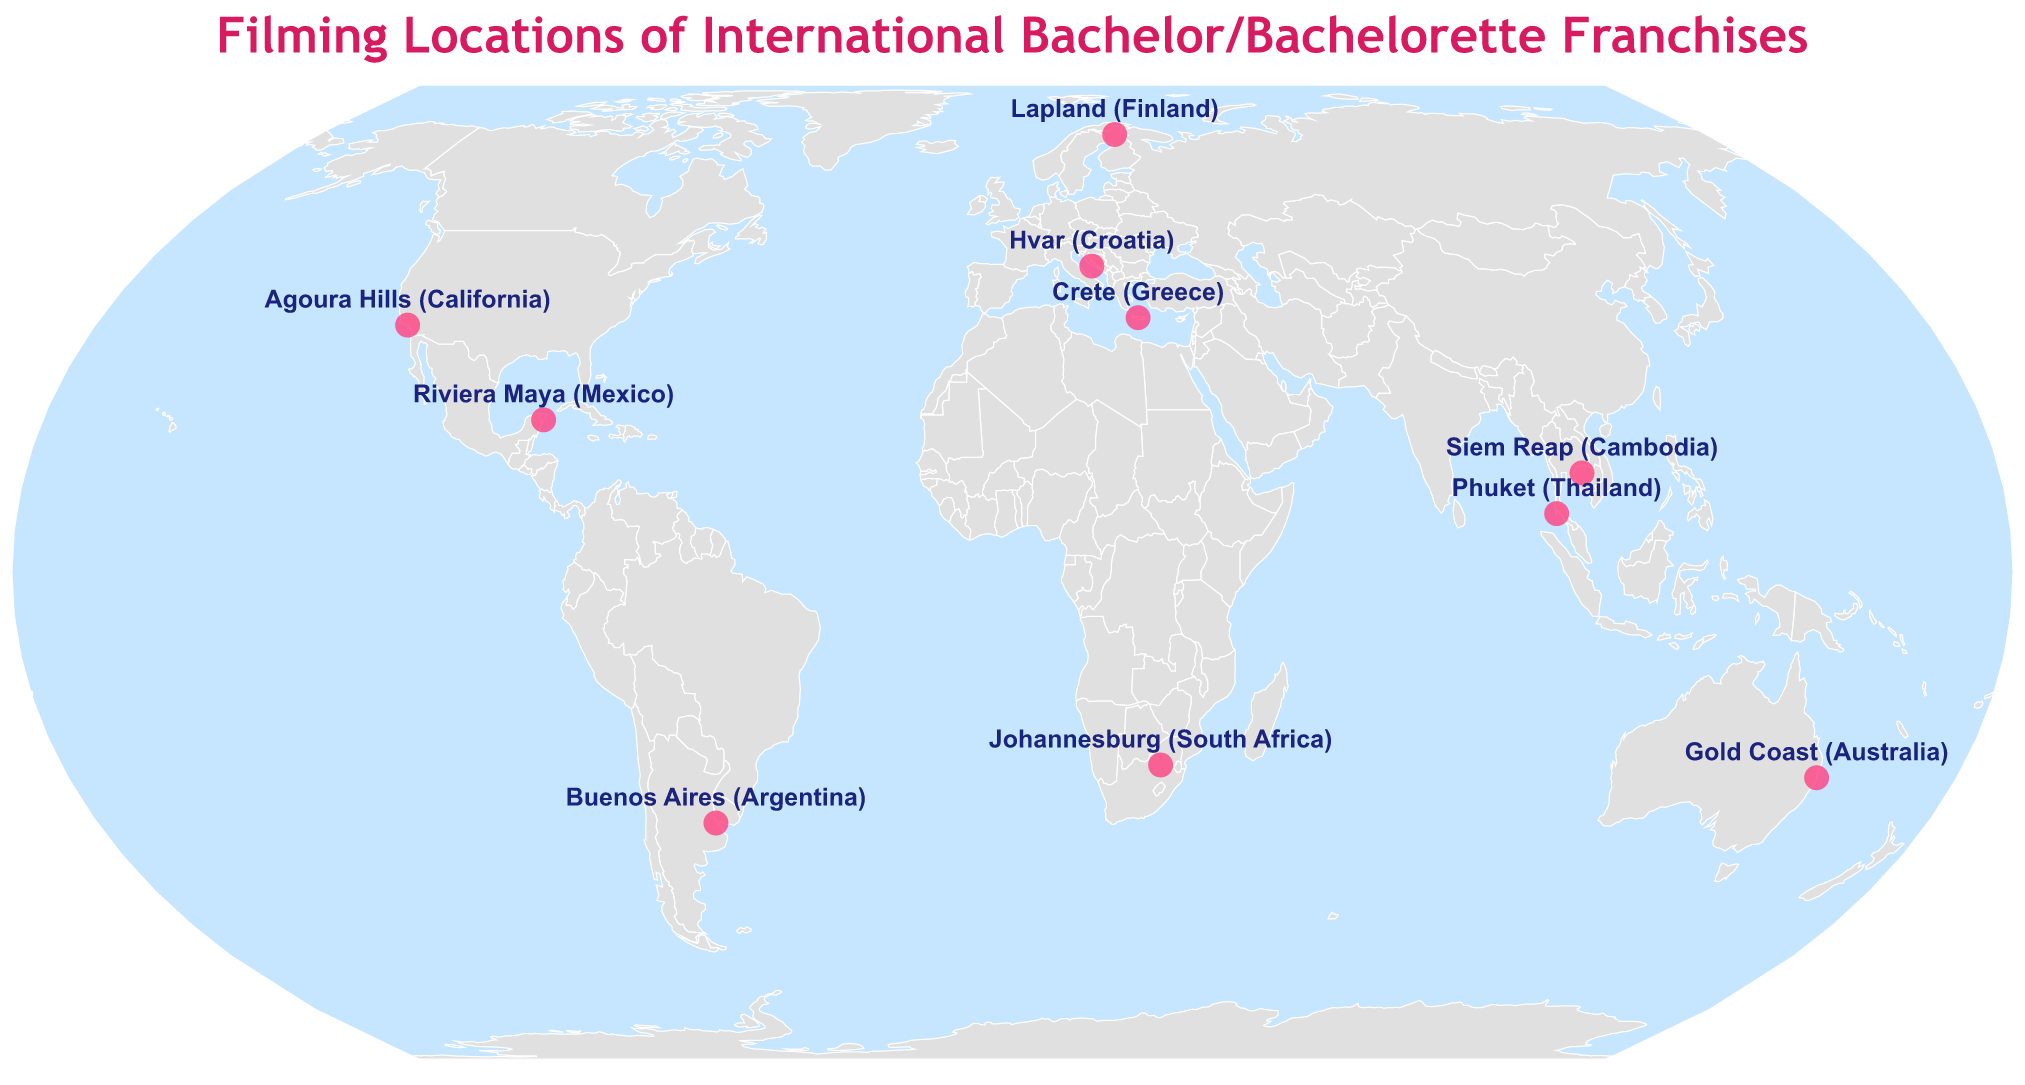what is the title of the plot? The title is often displayed prominently at the top of the plot in larger font size.
Answer: Filming Locations of International Bachelor/Bachelorette Franchises How many locations are shown for the "Bachelor in Paradise" series? By looking at the plot's markers and the corresponding tooltips, you can see specific entries for "Bachelor in Paradise". There are two locations mentioned: Riviera Maya (Mexico) and Phuket (Thailand).
Answer: Two Which filming location is situated in South Africa? By checking the plotted points and their labels marked on the figure, you can identify the one located in South Africa.
Answer: Johannesburg Where was "The Bachelor UK" filmed? Identify the marker associated with "The Bachelor UK" series by looking at the tooltips or marker labels on the plot.
Answer: Crete, Greece Which location is the northernmost among the filming locations? Notice the latitude values and compare their distances from the equator (0 degrees latitude), the highest positive latitude value indicates the northernmost point.
Answer: Lapland, Finland Compare the latitude of Gold Coast (Australia) and Buenos Aires (Argentina). Gold Coast has a latitude of -28.0167, while Buenos Aires has a latitude of -34.6037. Since -28.0167 is closer to zero than -34.6037, Gold Coast is further north than Buenos Aires.
Answer: Gold Coast is further north Are there more locations in the Northern Hemisphere or the Southern Hemisphere? Divide the locations based on the equator (latitude = 0); check which hemisphere—Northern (positive latitude) or Southern (negative latitude)—contains more locations. Northern Hemisphere has six points and Southern Hemisphere has four.
Answer: Northern Hemisphere Which two shows have multiple filming locations mentioned? Identify shows that appear with the "Multiple" season indicator next to different locations on the plot.
Answer: The Bachelor USA and Bachelor in Paradise Which filming location is closest to the equator? Compare the latitude values and find the one closest to zero. Phuket (Thailand) has the latitude 7.8804, which is the closest to the equator among all locations plotted.
Answer: Phuket, Thailand 